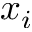Convert formula to latex. <formula><loc_0><loc_0><loc_500><loc_500>x _ { i }</formula> 